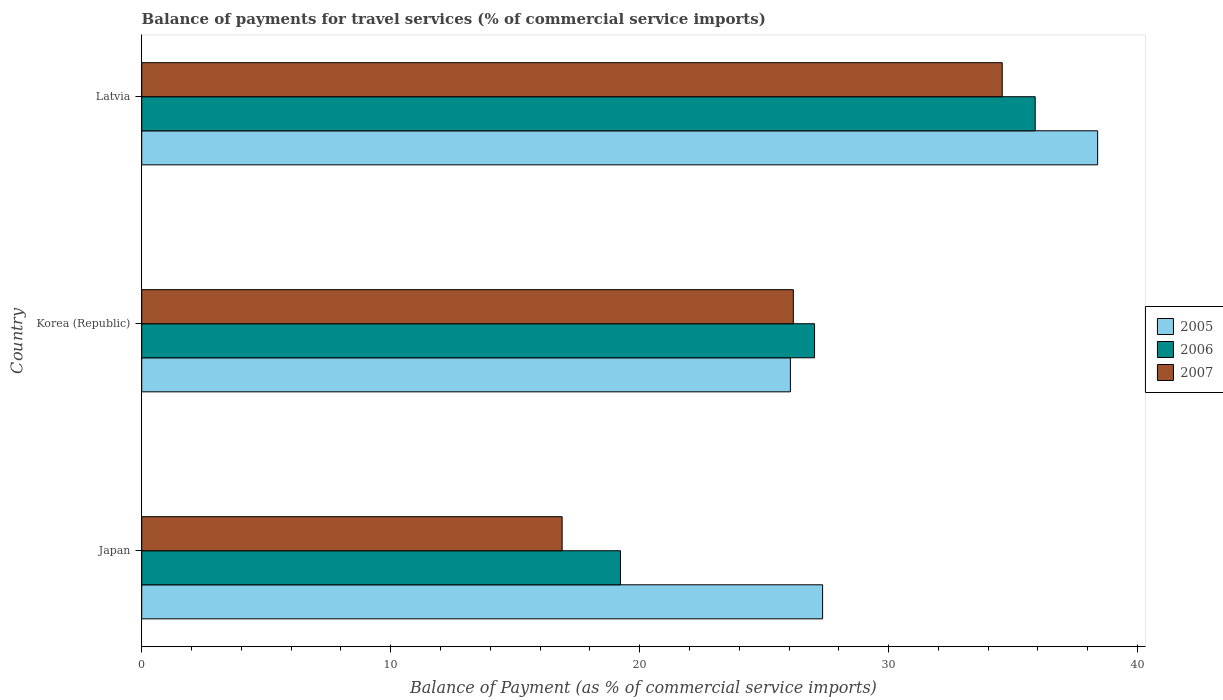How many different coloured bars are there?
Provide a short and direct response. 3. How many bars are there on the 2nd tick from the bottom?
Make the answer very short. 3. What is the label of the 3rd group of bars from the top?
Provide a succinct answer. Japan. In how many cases, is the number of bars for a given country not equal to the number of legend labels?
Keep it short and to the point. 0. What is the balance of payments for travel services in 2006 in Latvia?
Your answer should be compact. 35.89. Across all countries, what is the maximum balance of payments for travel services in 2007?
Provide a short and direct response. 34.56. Across all countries, what is the minimum balance of payments for travel services in 2006?
Your response must be concise. 19.23. In which country was the balance of payments for travel services in 2005 maximum?
Give a very brief answer. Latvia. What is the total balance of payments for travel services in 2006 in the graph?
Provide a short and direct response. 82.14. What is the difference between the balance of payments for travel services in 2005 in Korea (Republic) and that in Latvia?
Your answer should be compact. -12.34. What is the difference between the balance of payments for travel services in 2005 in Korea (Republic) and the balance of payments for travel services in 2007 in Latvia?
Your response must be concise. -8.51. What is the average balance of payments for travel services in 2005 per country?
Offer a very short reply. 30.6. What is the difference between the balance of payments for travel services in 2007 and balance of payments for travel services in 2006 in Korea (Republic)?
Make the answer very short. -0.85. What is the ratio of the balance of payments for travel services in 2005 in Japan to that in Latvia?
Make the answer very short. 0.71. Is the balance of payments for travel services in 2006 in Korea (Republic) less than that in Latvia?
Provide a succinct answer. Yes. Is the difference between the balance of payments for travel services in 2007 in Korea (Republic) and Latvia greater than the difference between the balance of payments for travel services in 2006 in Korea (Republic) and Latvia?
Make the answer very short. Yes. What is the difference between the highest and the second highest balance of payments for travel services in 2007?
Provide a succinct answer. 8.39. What is the difference between the highest and the lowest balance of payments for travel services in 2005?
Offer a very short reply. 12.34. Is the sum of the balance of payments for travel services in 2007 in Japan and Korea (Republic) greater than the maximum balance of payments for travel services in 2006 across all countries?
Ensure brevity in your answer.  Yes. What does the 1st bar from the bottom in Latvia represents?
Offer a very short reply. 2005. Is it the case that in every country, the sum of the balance of payments for travel services in 2005 and balance of payments for travel services in 2007 is greater than the balance of payments for travel services in 2006?
Keep it short and to the point. Yes. How many bars are there?
Give a very brief answer. 9. How many countries are there in the graph?
Make the answer very short. 3. What is the difference between two consecutive major ticks on the X-axis?
Your answer should be compact. 10. Are the values on the major ticks of X-axis written in scientific E-notation?
Provide a short and direct response. No. What is the title of the graph?
Offer a very short reply. Balance of payments for travel services (% of commercial service imports). What is the label or title of the X-axis?
Your answer should be compact. Balance of Payment (as % of commercial service imports). What is the label or title of the Y-axis?
Give a very brief answer. Country. What is the Balance of Payment (as % of commercial service imports) of 2005 in Japan?
Give a very brief answer. 27.35. What is the Balance of Payment (as % of commercial service imports) in 2006 in Japan?
Offer a very short reply. 19.23. What is the Balance of Payment (as % of commercial service imports) in 2007 in Japan?
Offer a very short reply. 16.89. What is the Balance of Payment (as % of commercial service imports) in 2005 in Korea (Republic)?
Your answer should be very brief. 26.06. What is the Balance of Payment (as % of commercial service imports) in 2006 in Korea (Republic)?
Your answer should be compact. 27.03. What is the Balance of Payment (as % of commercial service imports) in 2007 in Korea (Republic)?
Make the answer very short. 26.17. What is the Balance of Payment (as % of commercial service imports) of 2005 in Latvia?
Ensure brevity in your answer.  38.4. What is the Balance of Payment (as % of commercial service imports) of 2006 in Latvia?
Provide a succinct answer. 35.89. What is the Balance of Payment (as % of commercial service imports) in 2007 in Latvia?
Keep it short and to the point. 34.56. Across all countries, what is the maximum Balance of Payment (as % of commercial service imports) in 2005?
Your answer should be very brief. 38.4. Across all countries, what is the maximum Balance of Payment (as % of commercial service imports) of 2006?
Ensure brevity in your answer.  35.89. Across all countries, what is the maximum Balance of Payment (as % of commercial service imports) in 2007?
Your response must be concise. 34.56. Across all countries, what is the minimum Balance of Payment (as % of commercial service imports) in 2005?
Your response must be concise. 26.06. Across all countries, what is the minimum Balance of Payment (as % of commercial service imports) in 2006?
Give a very brief answer. 19.23. Across all countries, what is the minimum Balance of Payment (as % of commercial service imports) of 2007?
Make the answer very short. 16.89. What is the total Balance of Payment (as % of commercial service imports) in 2005 in the graph?
Your answer should be compact. 91.8. What is the total Balance of Payment (as % of commercial service imports) of 2006 in the graph?
Ensure brevity in your answer.  82.14. What is the total Balance of Payment (as % of commercial service imports) in 2007 in the graph?
Ensure brevity in your answer.  77.62. What is the difference between the Balance of Payment (as % of commercial service imports) of 2005 in Japan and that in Korea (Republic)?
Offer a terse response. 1.29. What is the difference between the Balance of Payment (as % of commercial service imports) of 2006 in Japan and that in Korea (Republic)?
Offer a terse response. -7.79. What is the difference between the Balance of Payment (as % of commercial service imports) of 2007 in Japan and that in Korea (Republic)?
Ensure brevity in your answer.  -9.29. What is the difference between the Balance of Payment (as % of commercial service imports) of 2005 in Japan and that in Latvia?
Provide a short and direct response. -11.05. What is the difference between the Balance of Payment (as % of commercial service imports) of 2006 in Japan and that in Latvia?
Offer a terse response. -16.66. What is the difference between the Balance of Payment (as % of commercial service imports) of 2007 in Japan and that in Latvia?
Your answer should be very brief. -17.68. What is the difference between the Balance of Payment (as % of commercial service imports) in 2005 in Korea (Republic) and that in Latvia?
Your response must be concise. -12.34. What is the difference between the Balance of Payment (as % of commercial service imports) of 2006 in Korea (Republic) and that in Latvia?
Make the answer very short. -8.86. What is the difference between the Balance of Payment (as % of commercial service imports) in 2007 in Korea (Republic) and that in Latvia?
Give a very brief answer. -8.39. What is the difference between the Balance of Payment (as % of commercial service imports) in 2005 in Japan and the Balance of Payment (as % of commercial service imports) in 2006 in Korea (Republic)?
Keep it short and to the point. 0.32. What is the difference between the Balance of Payment (as % of commercial service imports) of 2005 in Japan and the Balance of Payment (as % of commercial service imports) of 2007 in Korea (Republic)?
Make the answer very short. 1.17. What is the difference between the Balance of Payment (as % of commercial service imports) of 2006 in Japan and the Balance of Payment (as % of commercial service imports) of 2007 in Korea (Republic)?
Your answer should be very brief. -6.94. What is the difference between the Balance of Payment (as % of commercial service imports) of 2005 in Japan and the Balance of Payment (as % of commercial service imports) of 2006 in Latvia?
Give a very brief answer. -8.54. What is the difference between the Balance of Payment (as % of commercial service imports) in 2005 in Japan and the Balance of Payment (as % of commercial service imports) in 2007 in Latvia?
Offer a terse response. -7.22. What is the difference between the Balance of Payment (as % of commercial service imports) in 2006 in Japan and the Balance of Payment (as % of commercial service imports) in 2007 in Latvia?
Offer a very short reply. -15.33. What is the difference between the Balance of Payment (as % of commercial service imports) in 2005 in Korea (Republic) and the Balance of Payment (as % of commercial service imports) in 2006 in Latvia?
Offer a terse response. -9.83. What is the difference between the Balance of Payment (as % of commercial service imports) of 2005 in Korea (Republic) and the Balance of Payment (as % of commercial service imports) of 2007 in Latvia?
Give a very brief answer. -8.51. What is the difference between the Balance of Payment (as % of commercial service imports) of 2006 in Korea (Republic) and the Balance of Payment (as % of commercial service imports) of 2007 in Latvia?
Offer a very short reply. -7.54. What is the average Balance of Payment (as % of commercial service imports) of 2005 per country?
Offer a very short reply. 30.6. What is the average Balance of Payment (as % of commercial service imports) in 2006 per country?
Give a very brief answer. 27.38. What is the average Balance of Payment (as % of commercial service imports) in 2007 per country?
Your answer should be compact. 25.87. What is the difference between the Balance of Payment (as % of commercial service imports) in 2005 and Balance of Payment (as % of commercial service imports) in 2006 in Japan?
Your answer should be compact. 8.12. What is the difference between the Balance of Payment (as % of commercial service imports) of 2005 and Balance of Payment (as % of commercial service imports) of 2007 in Japan?
Provide a short and direct response. 10.46. What is the difference between the Balance of Payment (as % of commercial service imports) of 2006 and Balance of Payment (as % of commercial service imports) of 2007 in Japan?
Your answer should be compact. 2.34. What is the difference between the Balance of Payment (as % of commercial service imports) of 2005 and Balance of Payment (as % of commercial service imports) of 2006 in Korea (Republic)?
Your answer should be compact. -0.97. What is the difference between the Balance of Payment (as % of commercial service imports) of 2005 and Balance of Payment (as % of commercial service imports) of 2007 in Korea (Republic)?
Keep it short and to the point. -0.12. What is the difference between the Balance of Payment (as % of commercial service imports) in 2006 and Balance of Payment (as % of commercial service imports) in 2007 in Korea (Republic)?
Offer a very short reply. 0.85. What is the difference between the Balance of Payment (as % of commercial service imports) of 2005 and Balance of Payment (as % of commercial service imports) of 2006 in Latvia?
Offer a very short reply. 2.51. What is the difference between the Balance of Payment (as % of commercial service imports) in 2005 and Balance of Payment (as % of commercial service imports) in 2007 in Latvia?
Your response must be concise. 3.83. What is the difference between the Balance of Payment (as % of commercial service imports) in 2006 and Balance of Payment (as % of commercial service imports) in 2007 in Latvia?
Ensure brevity in your answer.  1.32. What is the ratio of the Balance of Payment (as % of commercial service imports) of 2005 in Japan to that in Korea (Republic)?
Provide a short and direct response. 1.05. What is the ratio of the Balance of Payment (as % of commercial service imports) in 2006 in Japan to that in Korea (Republic)?
Give a very brief answer. 0.71. What is the ratio of the Balance of Payment (as % of commercial service imports) of 2007 in Japan to that in Korea (Republic)?
Give a very brief answer. 0.65. What is the ratio of the Balance of Payment (as % of commercial service imports) in 2005 in Japan to that in Latvia?
Provide a short and direct response. 0.71. What is the ratio of the Balance of Payment (as % of commercial service imports) in 2006 in Japan to that in Latvia?
Your response must be concise. 0.54. What is the ratio of the Balance of Payment (as % of commercial service imports) of 2007 in Japan to that in Latvia?
Provide a succinct answer. 0.49. What is the ratio of the Balance of Payment (as % of commercial service imports) in 2005 in Korea (Republic) to that in Latvia?
Give a very brief answer. 0.68. What is the ratio of the Balance of Payment (as % of commercial service imports) of 2006 in Korea (Republic) to that in Latvia?
Offer a terse response. 0.75. What is the ratio of the Balance of Payment (as % of commercial service imports) in 2007 in Korea (Republic) to that in Latvia?
Offer a terse response. 0.76. What is the difference between the highest and the second highest Balance of Payment (as % of commercial service imports) in 2005?
Ensure brevity in your answer.  11.05. What is the difference between the highest and the second highest Balance of Payment (as % of commercial service imports) in 2006?
Make the answer very short. 8.86. What is the difference between the highest and the second highest Balance of Payment (as % of commercial service imports) of 2007?
Your response must be concise. 8.39. What is the difference between the highest and the lowest Balance of Payment (as % of commercial service imports) in 2005?
Provide a succinct answer. 12.34. What is the difference between the highest and the lowest Balance of Payment (as % of commercial service imports) of 2006?
Ensure brevity in your answer.  16.66. What is the difference between the highest and the lowest Balance of Payment (as % of commercial service imports) of 2007?
Give a very brief answer. 17.68. 